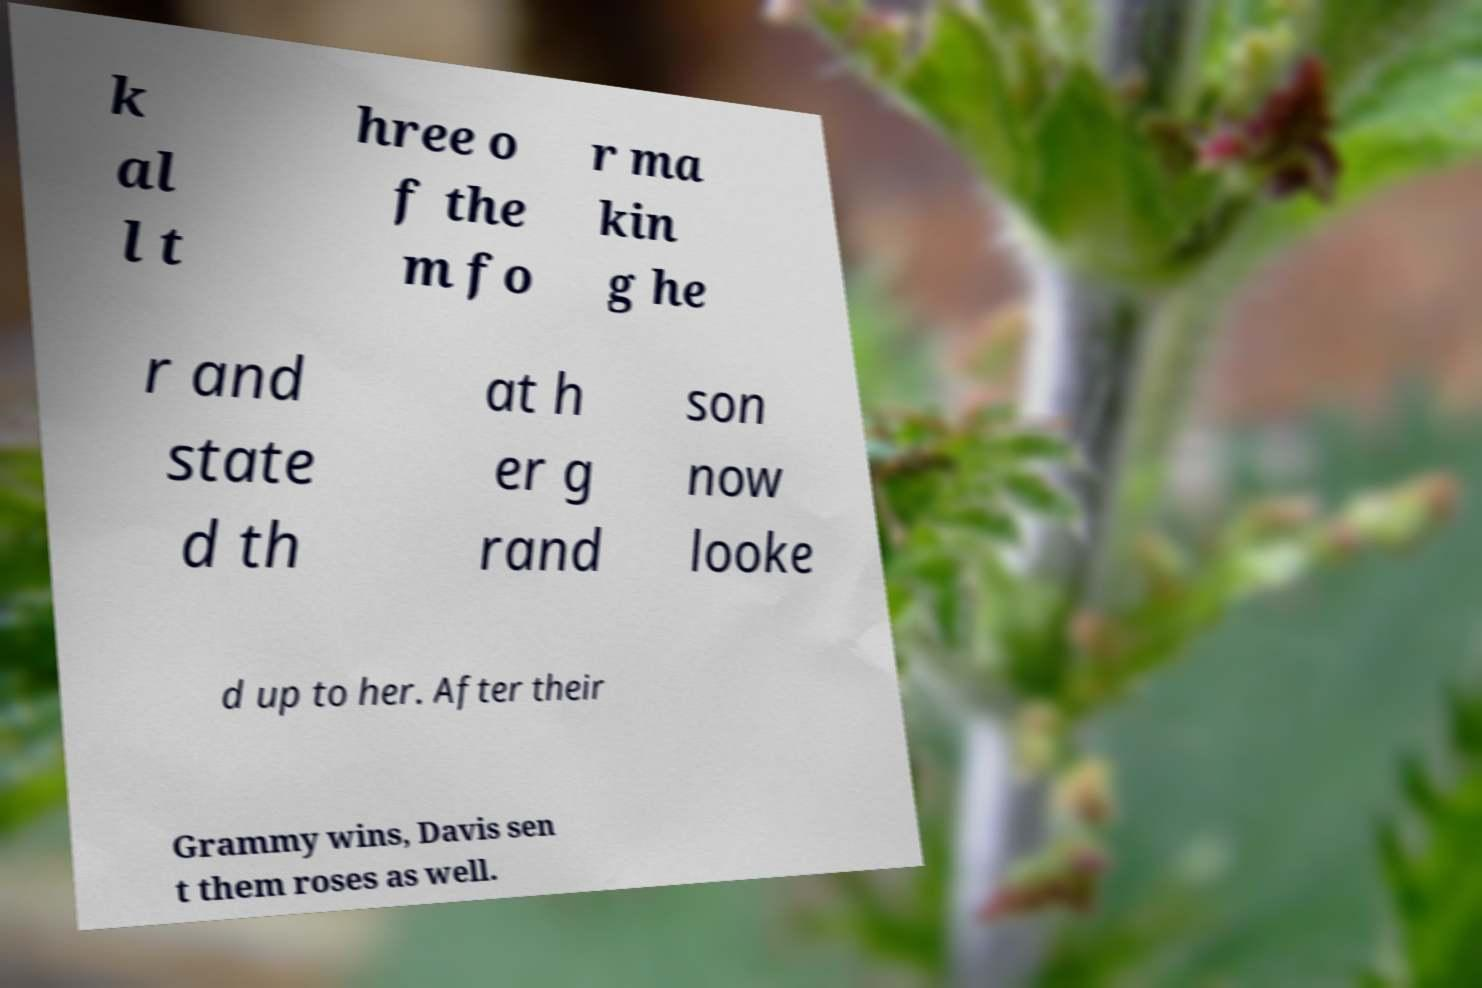What messages or text are displayed in this image? I need them in a readable, typed format. k al l t hree o f the m fo r ma kin g he r and state d th at h er g rand son now looke d up to her. After their Grammy wins, Davis sen t them roses as well. 